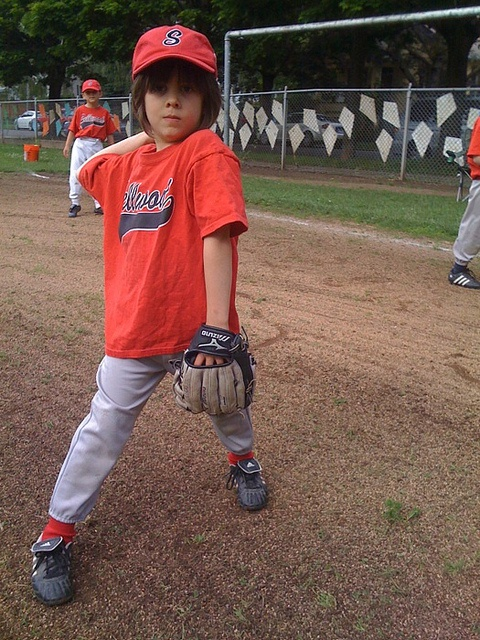Describe the objects in this image and their specific colors. I can see people in darkgreen, salmon, brown, gray, and black tones, baseball glove in darkgreen, gray, black, and maroon tones, people in darkgreen, lavender, brown, and maroon tones, car in darkgreen, gray, black, and darkgray tones, and people in darkgreen, darkgray, gray, and black tones in this image. 